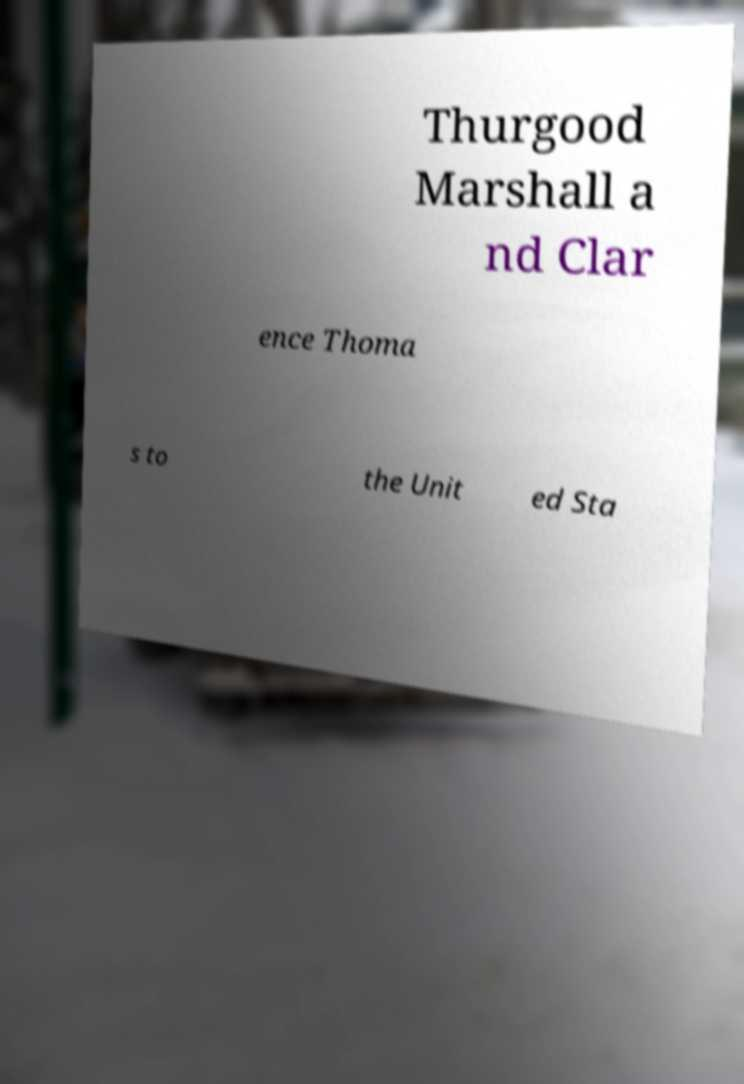For documentation purposes, I need the text within this image transcribed. Could you provide that? Thurgood Marshall a nd Clar ence Thoma s to the Unit ed Sta 